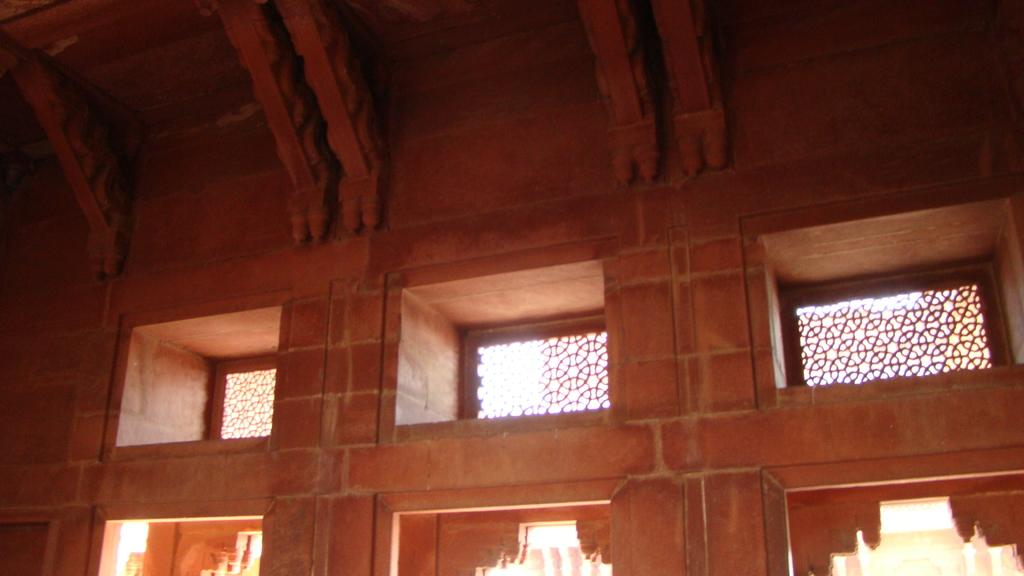What type of material is used for the windows in the image? The image contains designed glass windows. What is the father's belief about the texture of the windows in the image? There is no father or mention of beliefs in the image; it only features designed glass windows. 